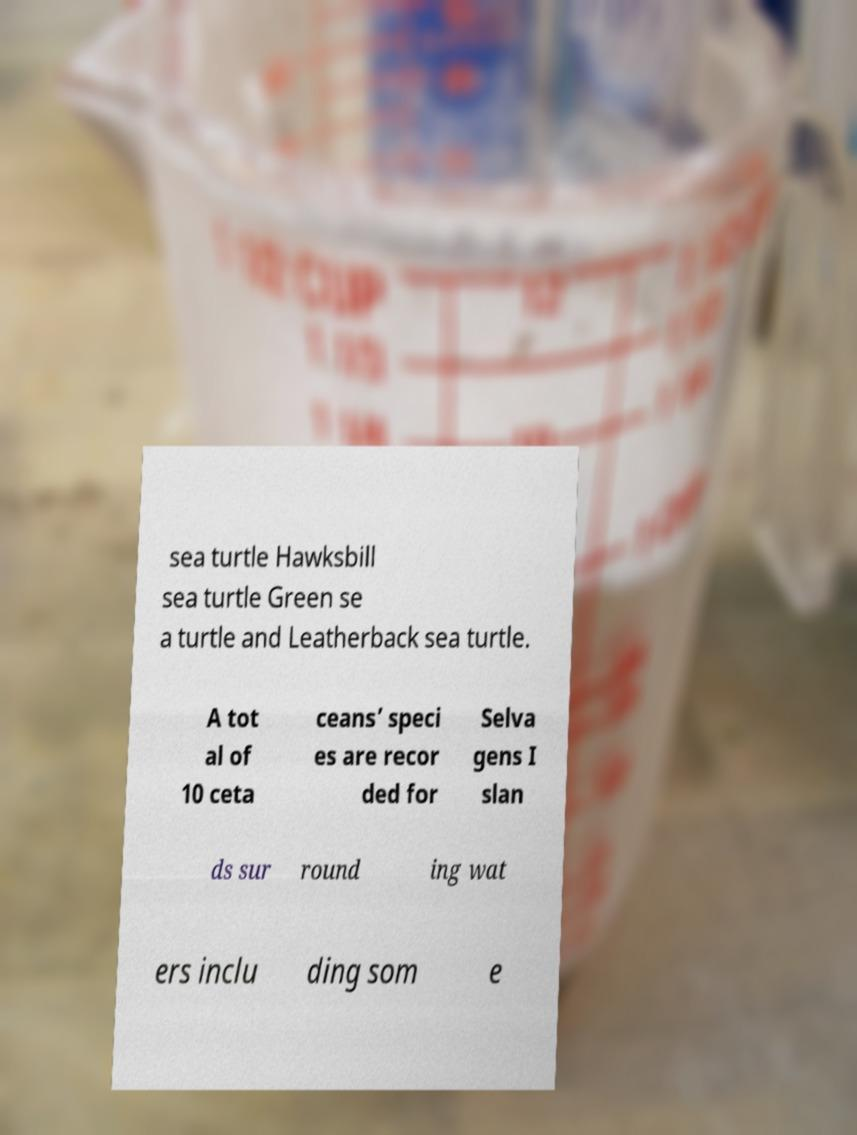Could you extract and type out the text from this image? sea turtle Hawksbill sea turtle Green se a turtle and Leatherback sea turtle. A tot al of 10 ceta ceans’ speci es are recor ded for Selva gens I slan ds sur round ing wat ers inclu ding som e 